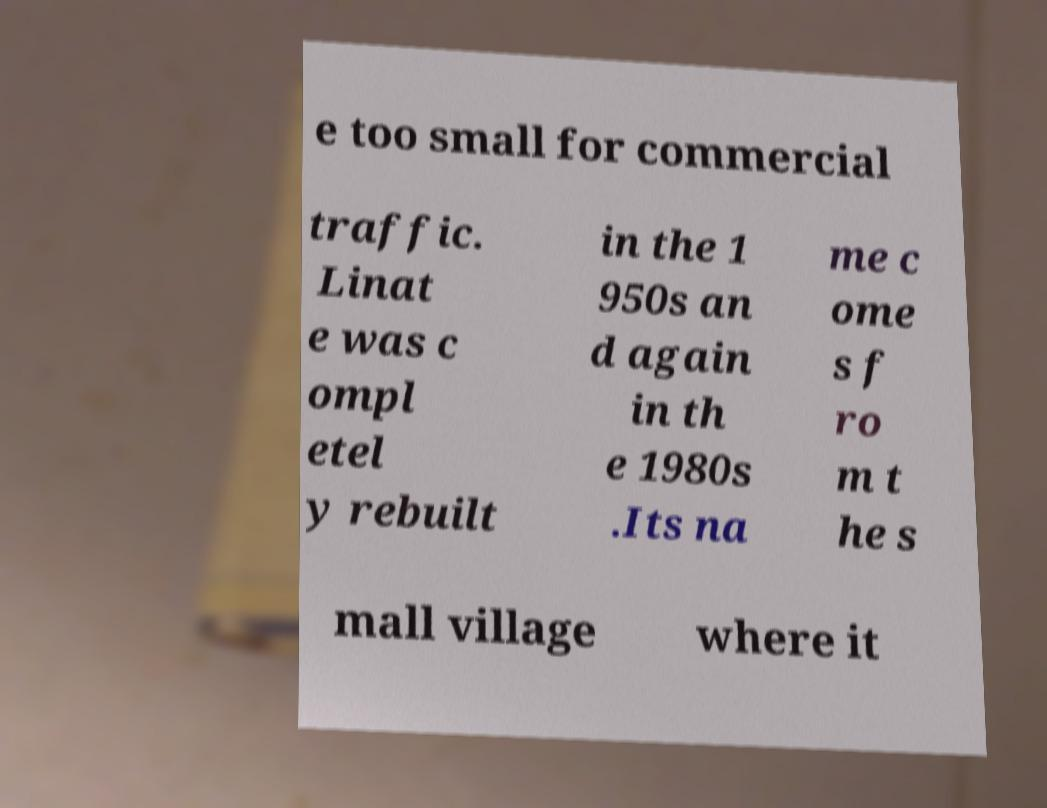There's text embedded in this image that I need extracted. Can you transcribe it verbatim? e too small for commercial traffic. Linat e was c ompl etel y rebuilt in the 1 950s an d again in th e 1980s .Its na me c ome s f ro m t he s mall village where it 